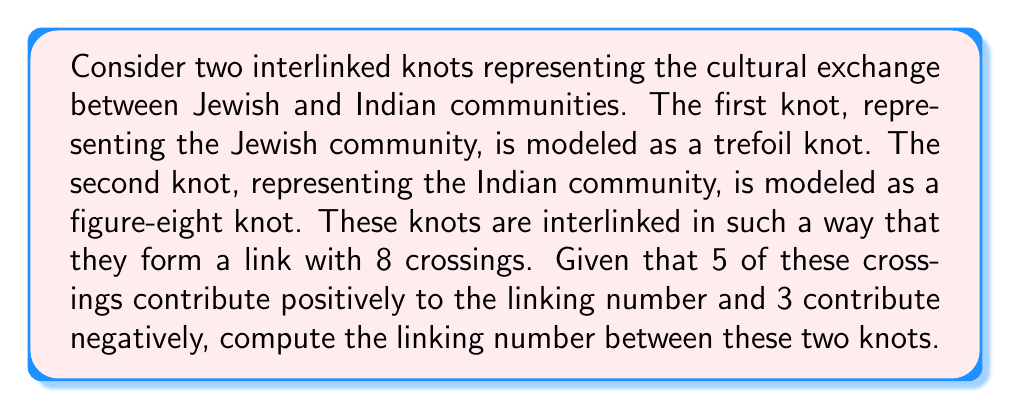Can you answer this question? Let's approach this step-by-step:

1) The linking number is a numerical invariant that describes how two closed curves are linked in three-dimensional space. It is calculated as half the sum of the signed crossings between the two curves.

2) In this case, we have two knots: a trefoil (representing the Jewish community) and a figure-eight (representing the Indian community), interlinked to form a link with 8 crossings.

3) The formula for the linking number is:

   $$Lk = \frac{1}{2} \sum_{i} \epsilon_i$$

   where $\epsilon_i$ is the sign of the $i$-th crossing (+1 for positive, -1 for negative).

4) We are given that:
   - 5 crossings contribute positively (+1 each)
   - 3 crossings contribute negatively (-1 each)

5) Let's sum up the contributions:
   $$\sum_{i} \epsilon_i = (5 \times (+1)) + (3 \times (-1)) = 5 - 3 = 2$$

6) Now, we can apply the formula:

   $$Lk = \frac{1}{2} \times 2 = 1$$

Therefore, the linking number between these two interlinked knots is 1.
Answer: 1 